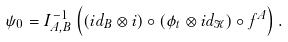Convert formula to latex. <formula><loc_0><loc_0><loc_500><loc_500>\psi _ { 0 } = I _ { A , B } ^ { - 1 } \left ( ( i d _ { B } \otimes i ) \circ ( \phi _ { t } \otimes i d _ { \mathcal { K } } ) \circ f ^ { A } \right ) .</formula> 